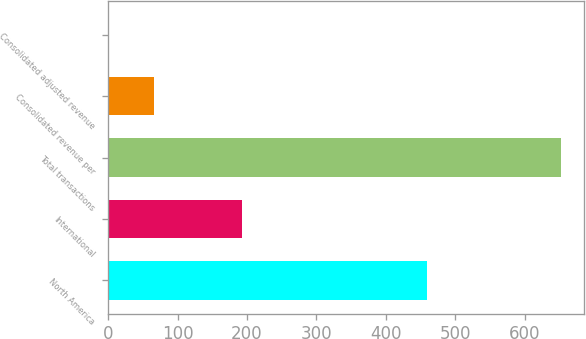Convert chart to OTSL. <chart><loc_0><loc_0><loc_500><loc_500><bar_chart><fcel>North America<fcel>International<fcel>Total transactions<fcel>Consolidated revenue per<fcel>Consolidated adjusted revenue<nl><fcel>459.9<fcel>192.5<fcel>652.4<fcel>66.76<fcel>1.69<nl></chart> 